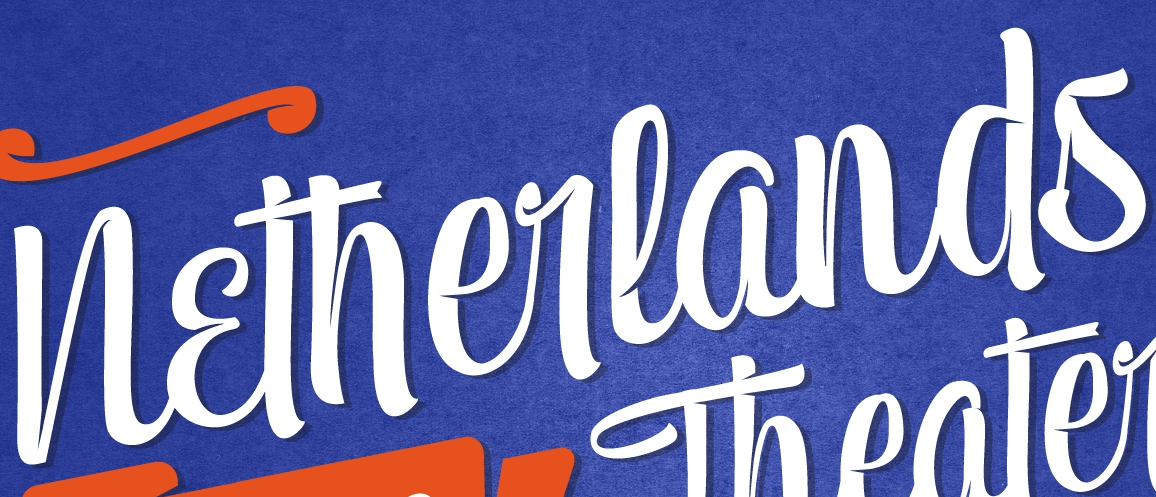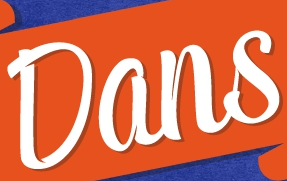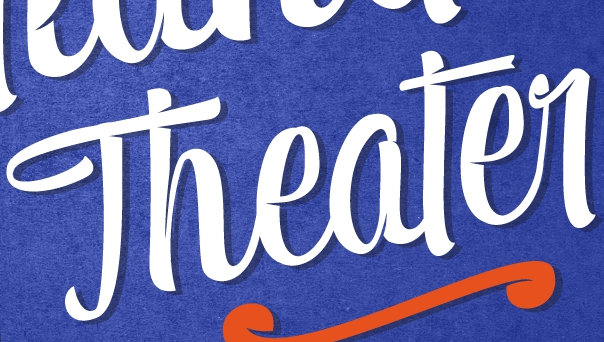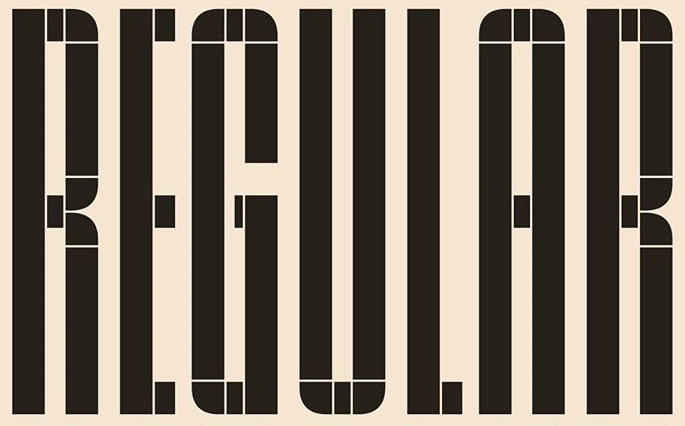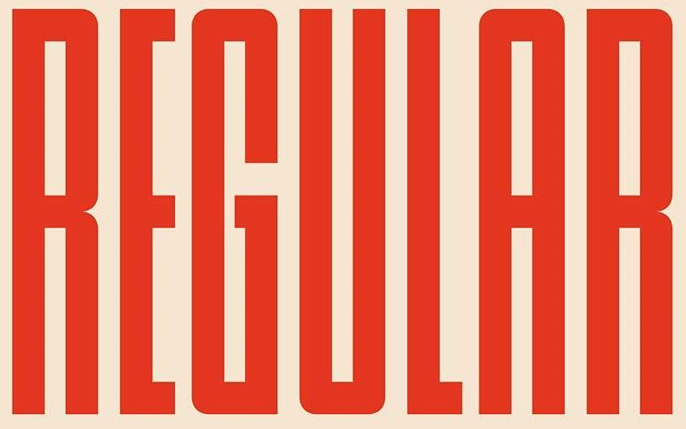What words are shown in these images in order, separated by a semicolon? Netherlands; Dans; Theater; REGULAR; REGULAR 